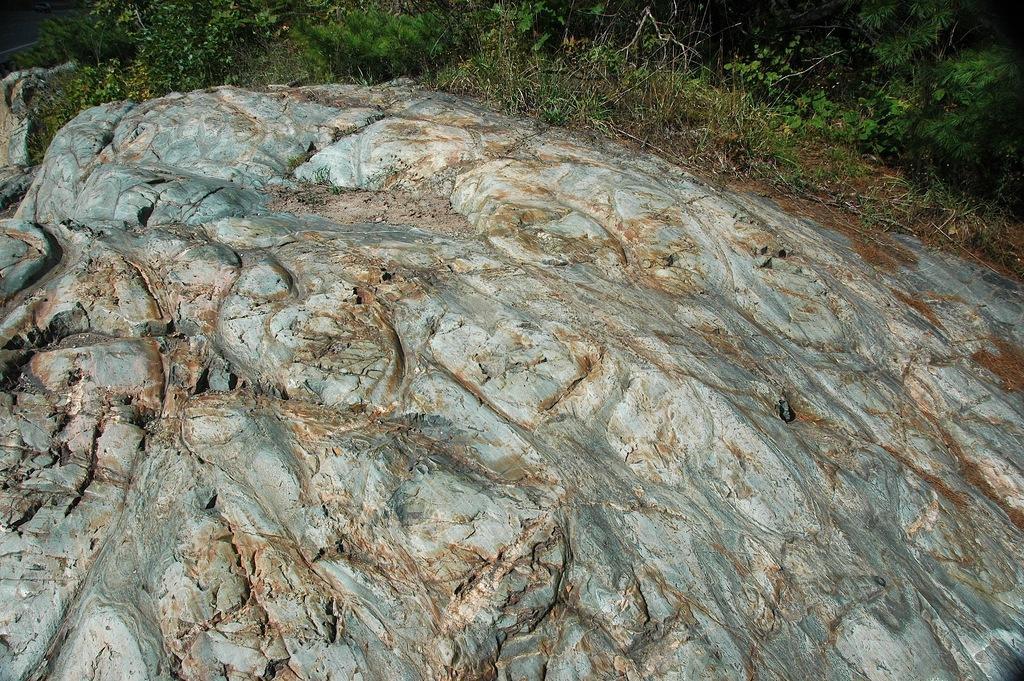How would you summarize this image in a sentence or two? In this image I can see the rock and few small plants in green color. 